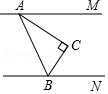Given the figure with points A, B, C, M, and N, where line segment AM is parallel to line segment BN, and angle ACB is a right angle while angle MAC measures 35 degrees, what is the degree measurement of angle CBN? To solve the problem, we first realize that line segments AM and BN are parallel, affording us the property that corresponding angles are equal. These parallel lines create several corresponding and supplementary angles that are key to solving for angle CBN. Given that angle ACB is a right angle, we know it measures 90 degrees. Since angle MAC measures 35 degrees, and considering the properties of parallel lines and transversals, angle CBN, which corresponds to angle MAC but oriented differently based on the geometric configuration, also measures 55 degrees by subtracting angle MAC from 90 degrees. Thus, the degree measure of angle CBN is 90 - 35 = 55 degrees. 